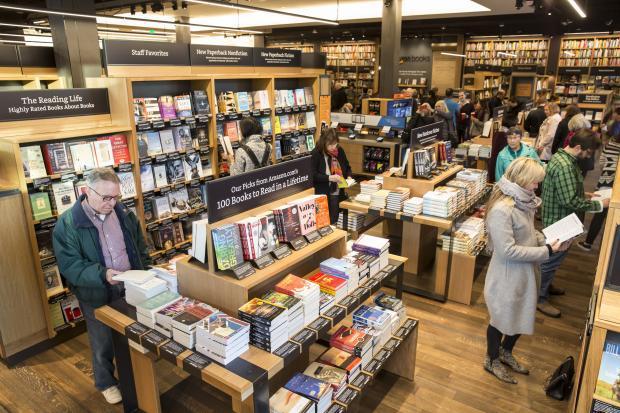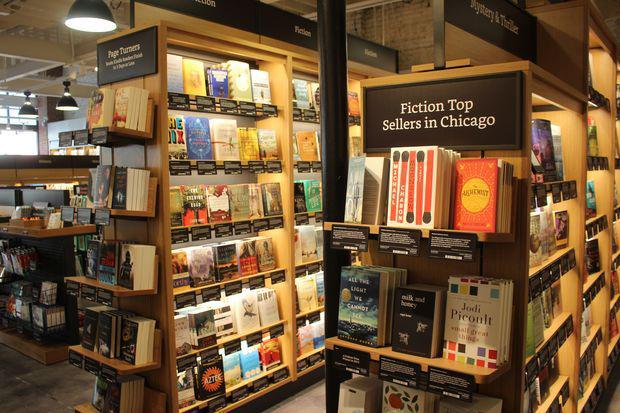The first image is the image on the left, the second image is the image on the right. Given the left and right images, does the statement "A person wearing black is standing on each side of one image, with a tiered stand of books topped with a horizontal black sign between the people." hold true? Answer yes or no. No. 